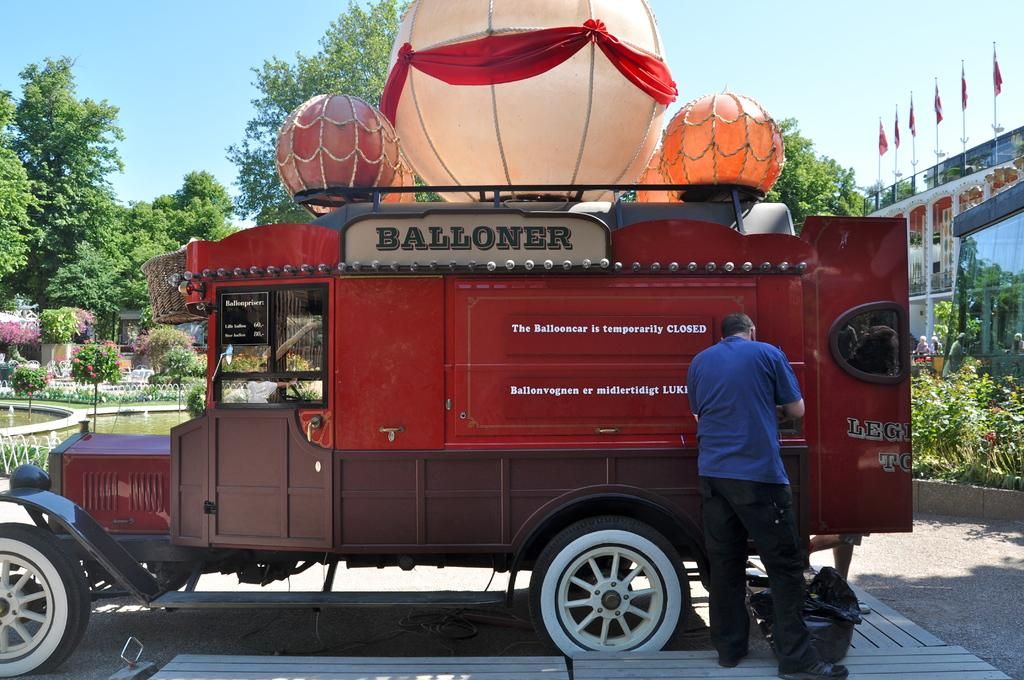Who is present in the image? There is a man in the image. What can be seen besides the man? There is a vehicle, a bag, plants, water, trees, flags, and some objects in the image. What is the background of the image? The sky is visible in the background of the image. How many bikes are being sorted in the image? There are no bikes present in the image, and no sorting activity is depicted. 